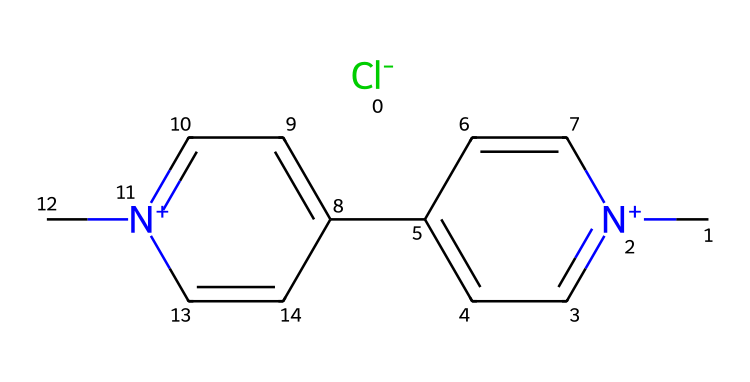What is the molecular formula of paraquat? To find the molecular formula, we identify the elements present in the SMILES representation and count the number of each type of atom. The structure includes carbon (C), nitrogen (N), and chlorine (Cl) atoms. Counting all the atoms gives us C12, H14, Cl, N2, which corresponds to the molecular formula C12H14ClN2.
Answer: C12H14ClN2 How many nitrogen atoms are present in paraquat? The SMILES representation indicates the presence of nitrogen atoms, denoted by the 'N' symbol. Counting the occurrences of ‘N’ in the chemical gives us 2 nitrogen atoms.
Answer: 2 What type of herbicide is paraquat? Paraquat is classified as a bipyridyl herbicide. The structure contains two pyridine rings connected by nitrogen atoms, which is characteristic of this type of herbicide.
Answer: bipyridyl What is the charge on the nitrogen atoms in paraquat? The nitrogen atoms in the SMILES representation are indicated with a '+' sign, showing they are positively charged. Therefore, both nitrogen atoms carry a positive charge.
Answer: positive Does paraquat contain any halogen atoms? In the SMILES notation, the presence of ‘Cl’ indicates chlorine, which is a halogen. Therefore, paraquat does contain a halogen atom.
Answer: yes How many aromatic rings are present in paraquat? The structure in the SMILES shows two distinct aromatic rings that are aromatic due to the alternating double bonds. Hence, we count two aromatic rings in the molecule.
Answer: 2 What are the potential risks of paraquat to wildlife? Paraquat is highly toxic to many forms of wildlife, including birds and mammals. Its mechanism of action can lead to oxidative stress and cellular damage, which poses significant health risks.
Answer: high toxicity 